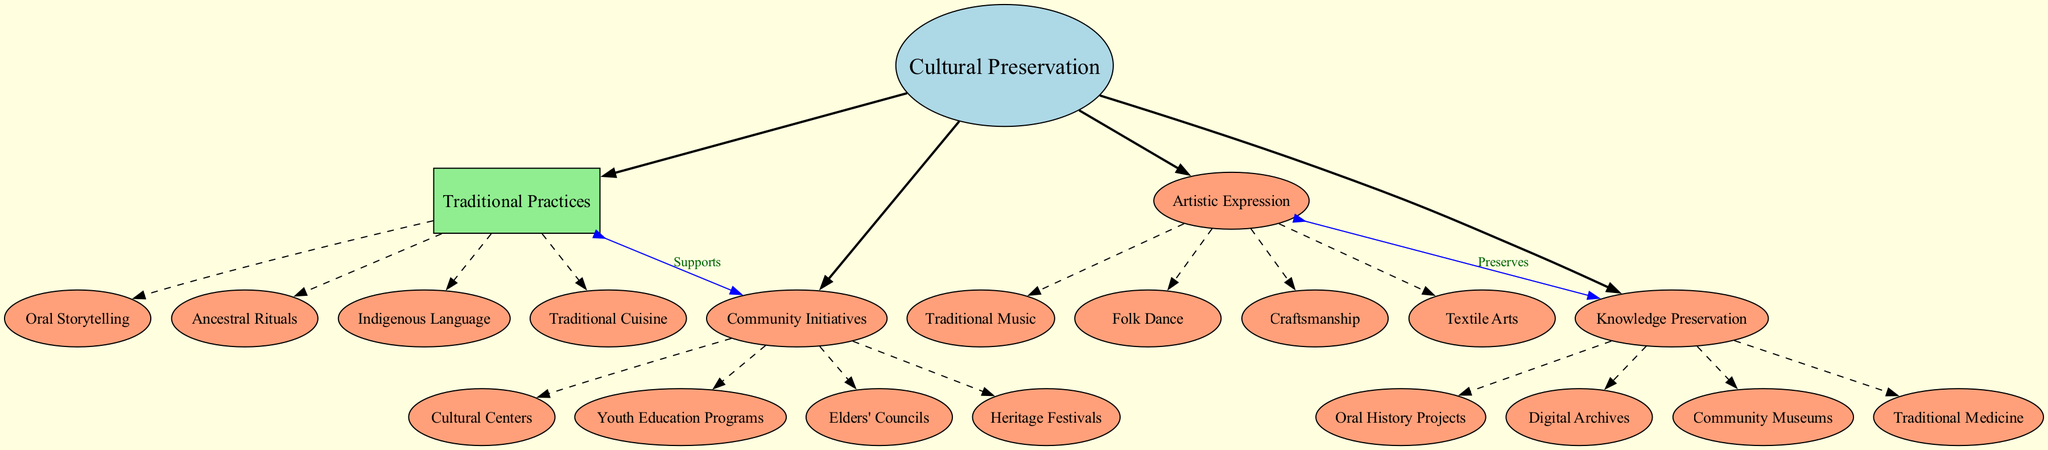What is the central concept of the diagram? The central concept, which is the main idea represented in the diagram, is explicitly labeled as "Cultural Preservation." Since it is the primary focus around which all other elements revolve, identifying it requires looking for the leading ellipsis shape containing a major title.
Answer: Cultural Preservation How many main branches are there? The diagram can be analyzed by counting the main branches connected to the central concept. There are four main branches shown, each representing a different aspect of cultural preservation. By simply enumerating the connections leading to the box-shaped nodes from the central concept, the total can be determined.
Answer: 4 Which sub-concept is associated with "Traditional Practices"? By examining the "Traditional Practices" branch, we find the associated sub-concepts listed under it. The sub-concepts provide specific examples of traditional practices, and one of them can easily be selected. In this case, "Oral Storytelling" is directly connected as a sub-concept.
Answer: Oral Storytelling What does "Artistic Expression" preserve? Looking at the connection from "Artistic Expression" to "Knowledge Preservation," it is essential to recognize that the label indicates a preservation relationship between these two elements. Thus, the content under "Knowledge Preservation" can be explored to find what it is preserving, specifically identifying one of the sub-concepts directly linked. In this case, "Folk Dance" is one example.
Answer: Knowledge Preservation How are "Traditional Practices" and "Community Initiatives" related? To answer this, we need to focus on the line connecting "Traditional Practices" to "Community Initiatives," which is labeled "Supports." This indicates that the practices listed under "Traditional Practices" actively assist in the formation or function of the initiatives in the other branch.
Answer: Supports Name two sub-concepts under "Community Initiatives." Observing the "Community Initiatives" branch, the diagram lists multiple sub-concepts. To answer the question, simply choose any two of the four provided examples, such as "Cultural Centers" and "Elders' Councils." These can be located by reviewing the names listed below the "Community Initiatives" node.
Answer: Cultural Centers, Elders' Councils What type of node represents the sub-concepts in the diagram? By distinguishing the shapes used in the diagram, we can see that the sub-concepts are represented with an ellipse shape. Noting the node shape assigned to the sub-concepts provides clarity on how they differ visually from the main branches.
Answer: Ellipse Which branch includes "Traditional Medicine"? To determine the correct branch, we need to look through the different main branches listed in the diagram and locate where "Traditional Medicine" appears. This particular sub-concept is found under the "Knowledge Preservation" branch.
Answer: Knowledge Preservation 